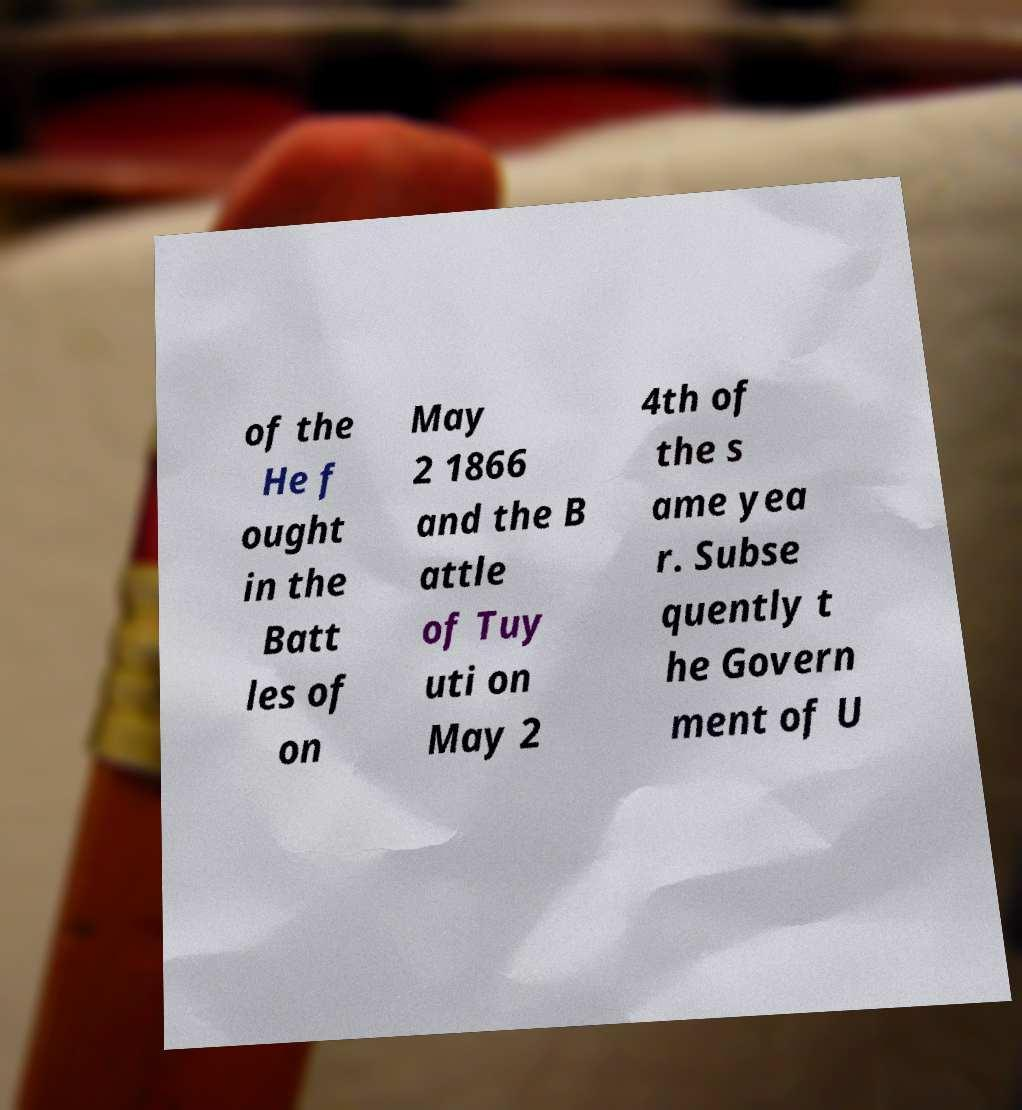Please identify and transcribe the text found in this image. of the He f ought in the Batt les of on May 2 1866 and the B attle of Tuy uti on May 2 4th of the s ame yea r. Subse quently t he Govern ment of U 